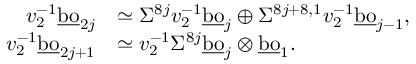Convert formula to latex. <formula><loc_0><loc_0><loc_500><loc_500>\begin{array} { r l } { v _ { 2 } ^ { - 1 } \underline { b o } _ { 2 j } } & { \simeq \Sigma ^ { 8 j } v _ { 2 } ^ { - 1 } \underline { b o } _ { j } \oplus \Sigma ^ { 8 j + 8 , 1 } v _ { 2 } ^ { - 1 } \underline { b o } _ { j - 1 } , } \\ { v _ { 2 } ^ { - 1 } \underline { b o } _ { 2 j + 1 } } & { \simeq v _ { 2 } ^ { - 1 } \Sigma ^ { 8 j } \underline { b o } _ { j } \otimes \underline { b o } _ { 1 } . } \end{array}</formula> 